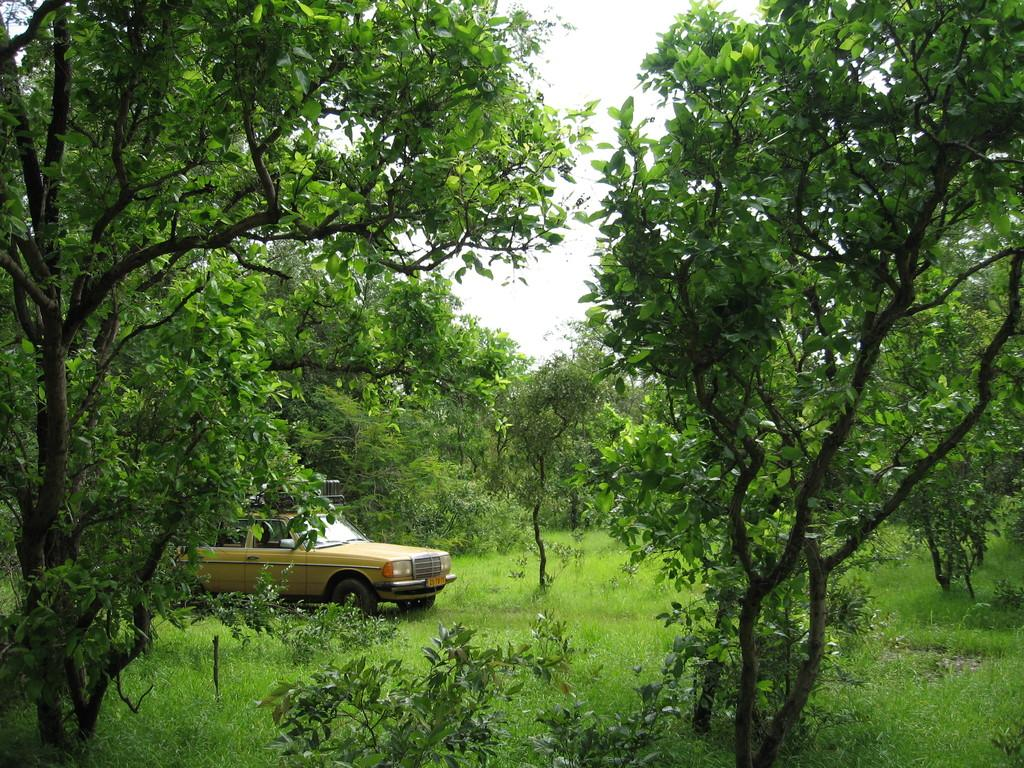What is the main subject of the image? There is a car in the image. How is the car positioned in the image? The car is placed on the ground. What type of vegetation can be seen in the image? There are plants, grass, and a group of trees in the image. What part of the natural environment is visible in the image? The sky is visible in the image. What is the condition of the sky in the image? The sky appears to be cloudy in the image. What type of silk material is draped over the car in the image? There is no silk material present in the image; it features a car on the ground with plants, grass, trees, and a cloudy sky. 